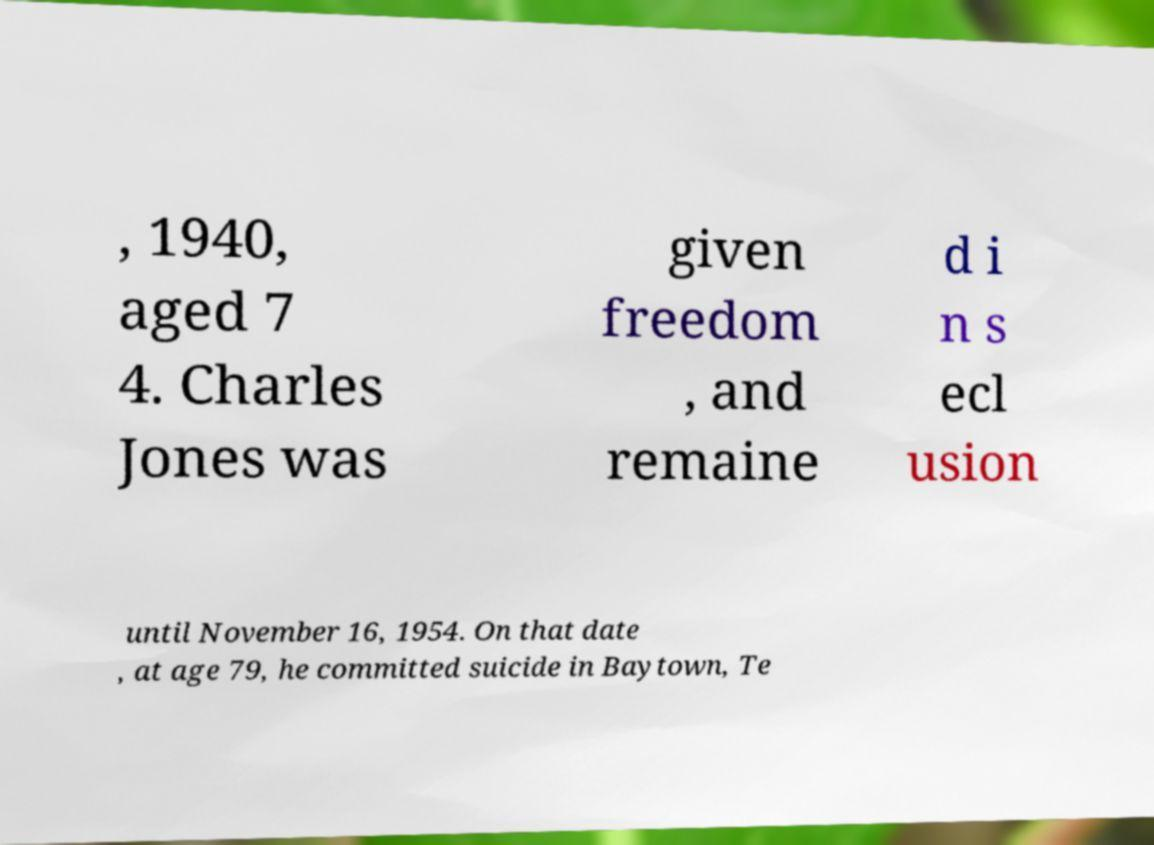Please read and relay the text visible in this image. What does it say? , 1940, aged 7 4. Charles Jones was given freedom , and remaine d i n s ecl usion until November 16, 1954. On that date , at age 79, he committed suicide in Baytown, Te 